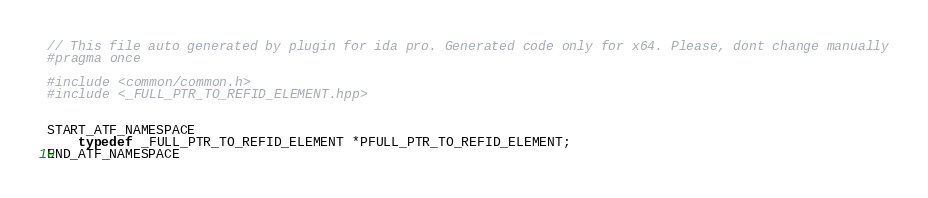<code> <loc_0><loc_0><loc_500><loc_500><_C++_>// This file auto generated by plugin for ida pro. Generated code only for x64. Please, dont change manually
#pragma once

#include <common/common.h>
#include <_FULL_PTR_TO_REFID_ELEMENT.hpp>


START_ATF_NAMESPACE
    typedef _FULL_PTR_TO_REFID_ELEMENT *PFULL_PTR_TO_REFID_ELEMENT;
END_ATF_NAMESPACE
</code> 